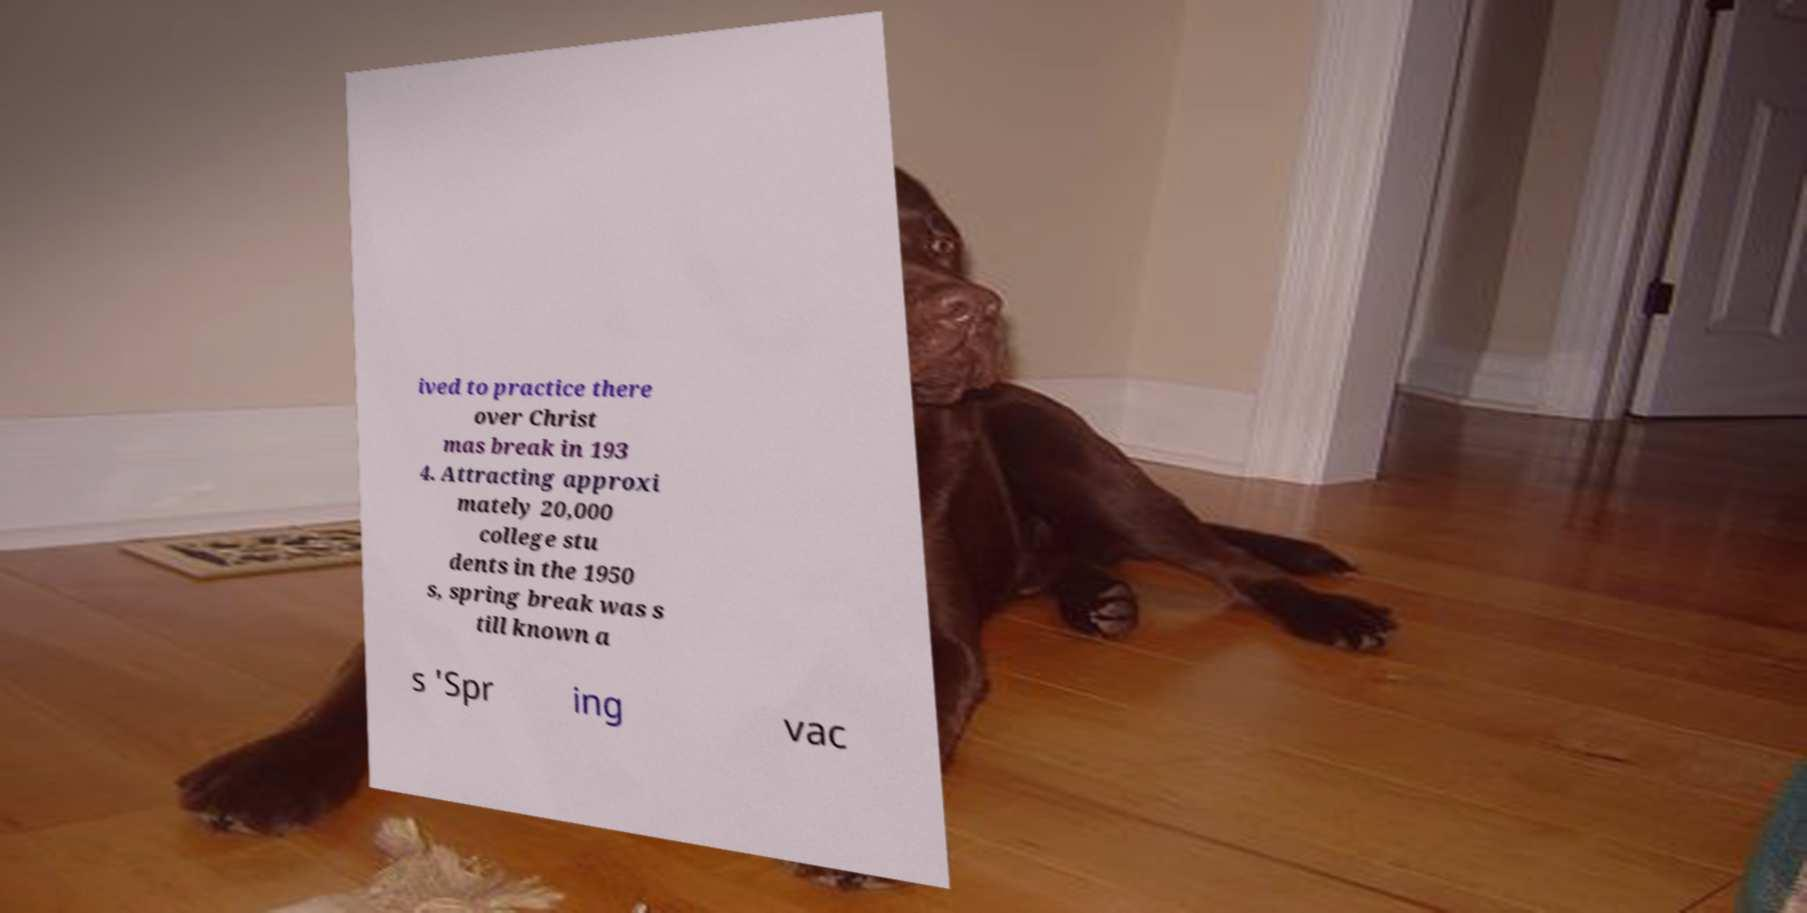Could you assist in decoding the text presented in this image and type it out clearly? ived to practice there over Christ mas break in 193 4. Attracting approxi mately 20,000 college stu dents in the 1950 s, spring break was s till known a s 'Spr ing vac 